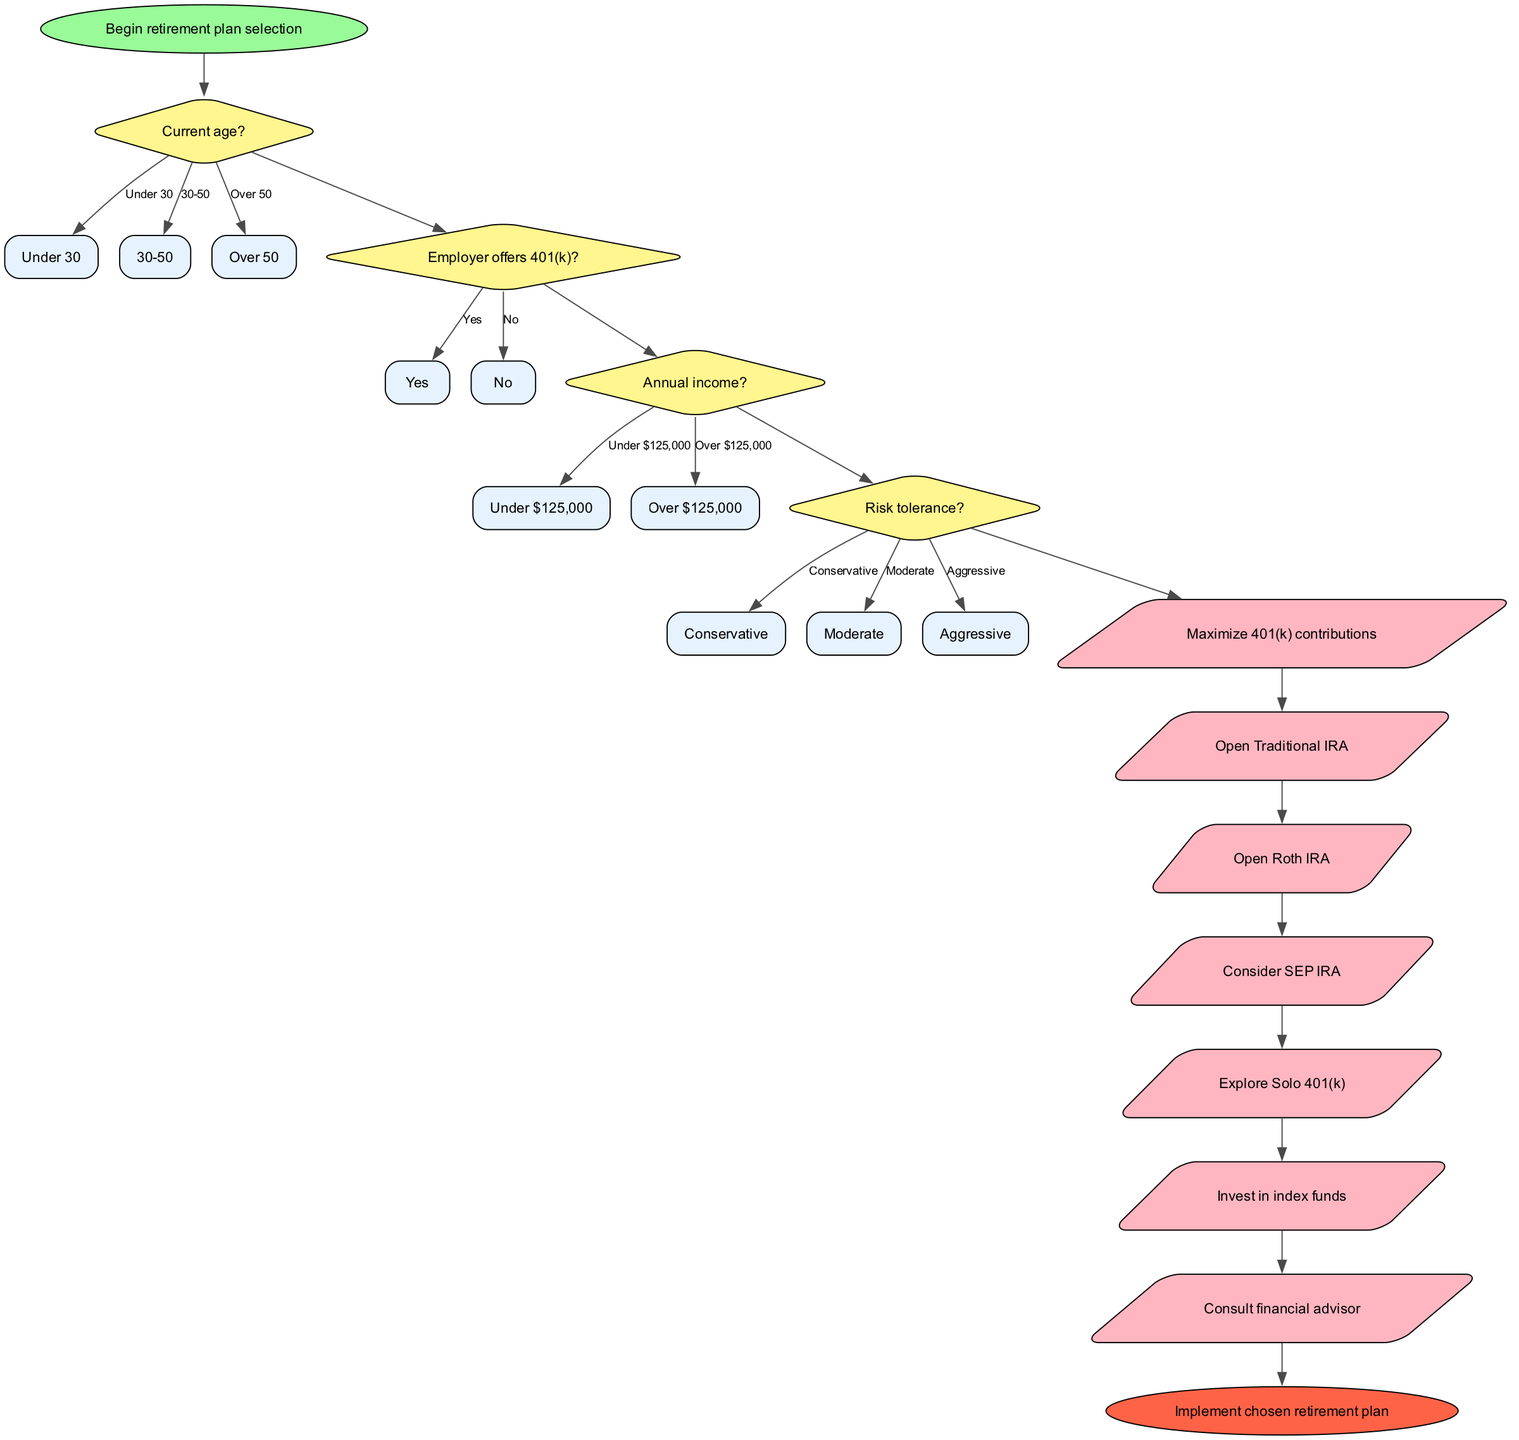What is the starting point of the diagram? The starting point is defined at the very beginning of the diagram and is labeled as "Begin retirement plan selection." It is depicted as an oval shape node, indicating the start of the process.
Answer: Begin retirement plan selection How many decision nodes are present in the diagram? The decision nodes are identified by the diamond shapes in the diagram. By counting the diamond-shaped nodes, we see there are four distinct decision points: age, employer offering 401(k), annual income, and risk tolerance.
Answer: 4 What action follows the decision on risk tolerance if it's aggressive? If the risk tolerance decision is "Aggressive," the flow would likely lead to an action node related to investing. However, since the specific action nodes are not directly connected to options within the flowchart, we can observe that the consequent actions involve investing in index funds.
Answer: Invest in index funds What is the last action before reaching the end of the diagram? The flow of the diagram progresses through the actions until the final action node is reached. The last action before concluding the flow with the end node is "Consult financial advisor."
Answer: Consult financial advisor What happens if the employer does not offer a 401(k)? When reaching the decision node for "Employer offers 401(k)?" and the answer is "No," the flow would not direct to actions related to 401(k) contributions. Instead, it leads to exploring other retirement options such as opening IRAs.
Answer: Open Traditional IRA What question comes after deciding on age group 30-50? After identifying the age group as 30-50, the subsequent decision node in the flowchart is related to whether the employer offers a 401(k). Thus, it flows directly to the next decision question.
Answer: Employer offers 401(k)? How is the connection between decision nodes and action nodes structured? The connection starts from the initial decision node related to age and continues to the next decision nodes in a sequential manner. Once the decisions are concluded, the flow moves to action nodes that represent the steps to be taken based on the prior decisions, each action node corresponds to a specific outcome from the final decision.
Answer: Sequentially until action nodes What are the options listed under the "Risk tolerance?" decision? The options provided for the "Risk tolerance?" decision are categorized into three distinct levels: Conservative, Moderate, and Aggressive. These options help assess one's investment strategy based on their comfort with risk.
Answer: Conservative, Moderate, Aggressive What color is used for the end node in the diagram? The end node is visually distinct in color; it is represented in a reddish color, specifically labeled as "Implement chosen retirement plan." The color choice emphasizes the completion of the selection process.
Answer: Red 